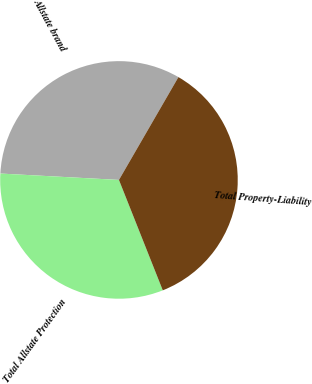<chart> <loc_0><loc_0><loc_500><loc_500><pie_chart><fcel>Allstate brand<fcel>Total Allstate Protection<fcel>Total Property-Liability<nl><fcel>32.49%<fcel>31.87%<fcel>35.64%<nl></chart> 